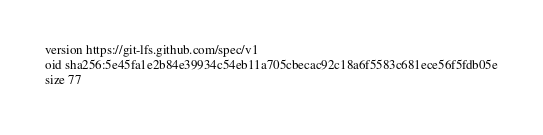<code> <loc_0><loc_0><loc_500><loc_500><_YAML_>version https://git-lfs.github.com/spec/v1
oid sha256:5e45fa1e2b84e39934c54eb11a705cbecac92c18a6f5583c681ece56f5fdb05e
size 77
</code> 